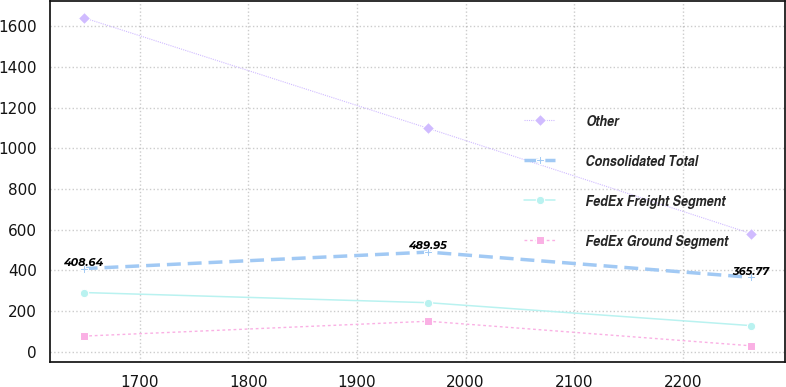Convert chart to OTSL. <chart><loc_0><loc_0><loc_500><loc_500><line_chart><ecel><fcel>Other<fcel>Consolidated Total<fcel>FedEx Freight Segment<fcel>FedEx Ground Segment<nl><fcel>1648.16<fcel>1641.66<fcel>408.64<fcel>291.12<fcel>76.92<nl><fcel>1965.66<fcel>1098<fcel>489.95<fcel>241.17<fcel>149.94<nl><fcel>2263.08<fcel>580.55<fcel>365.77<fcel>128.41<fcel>29.32<nl></chart> 